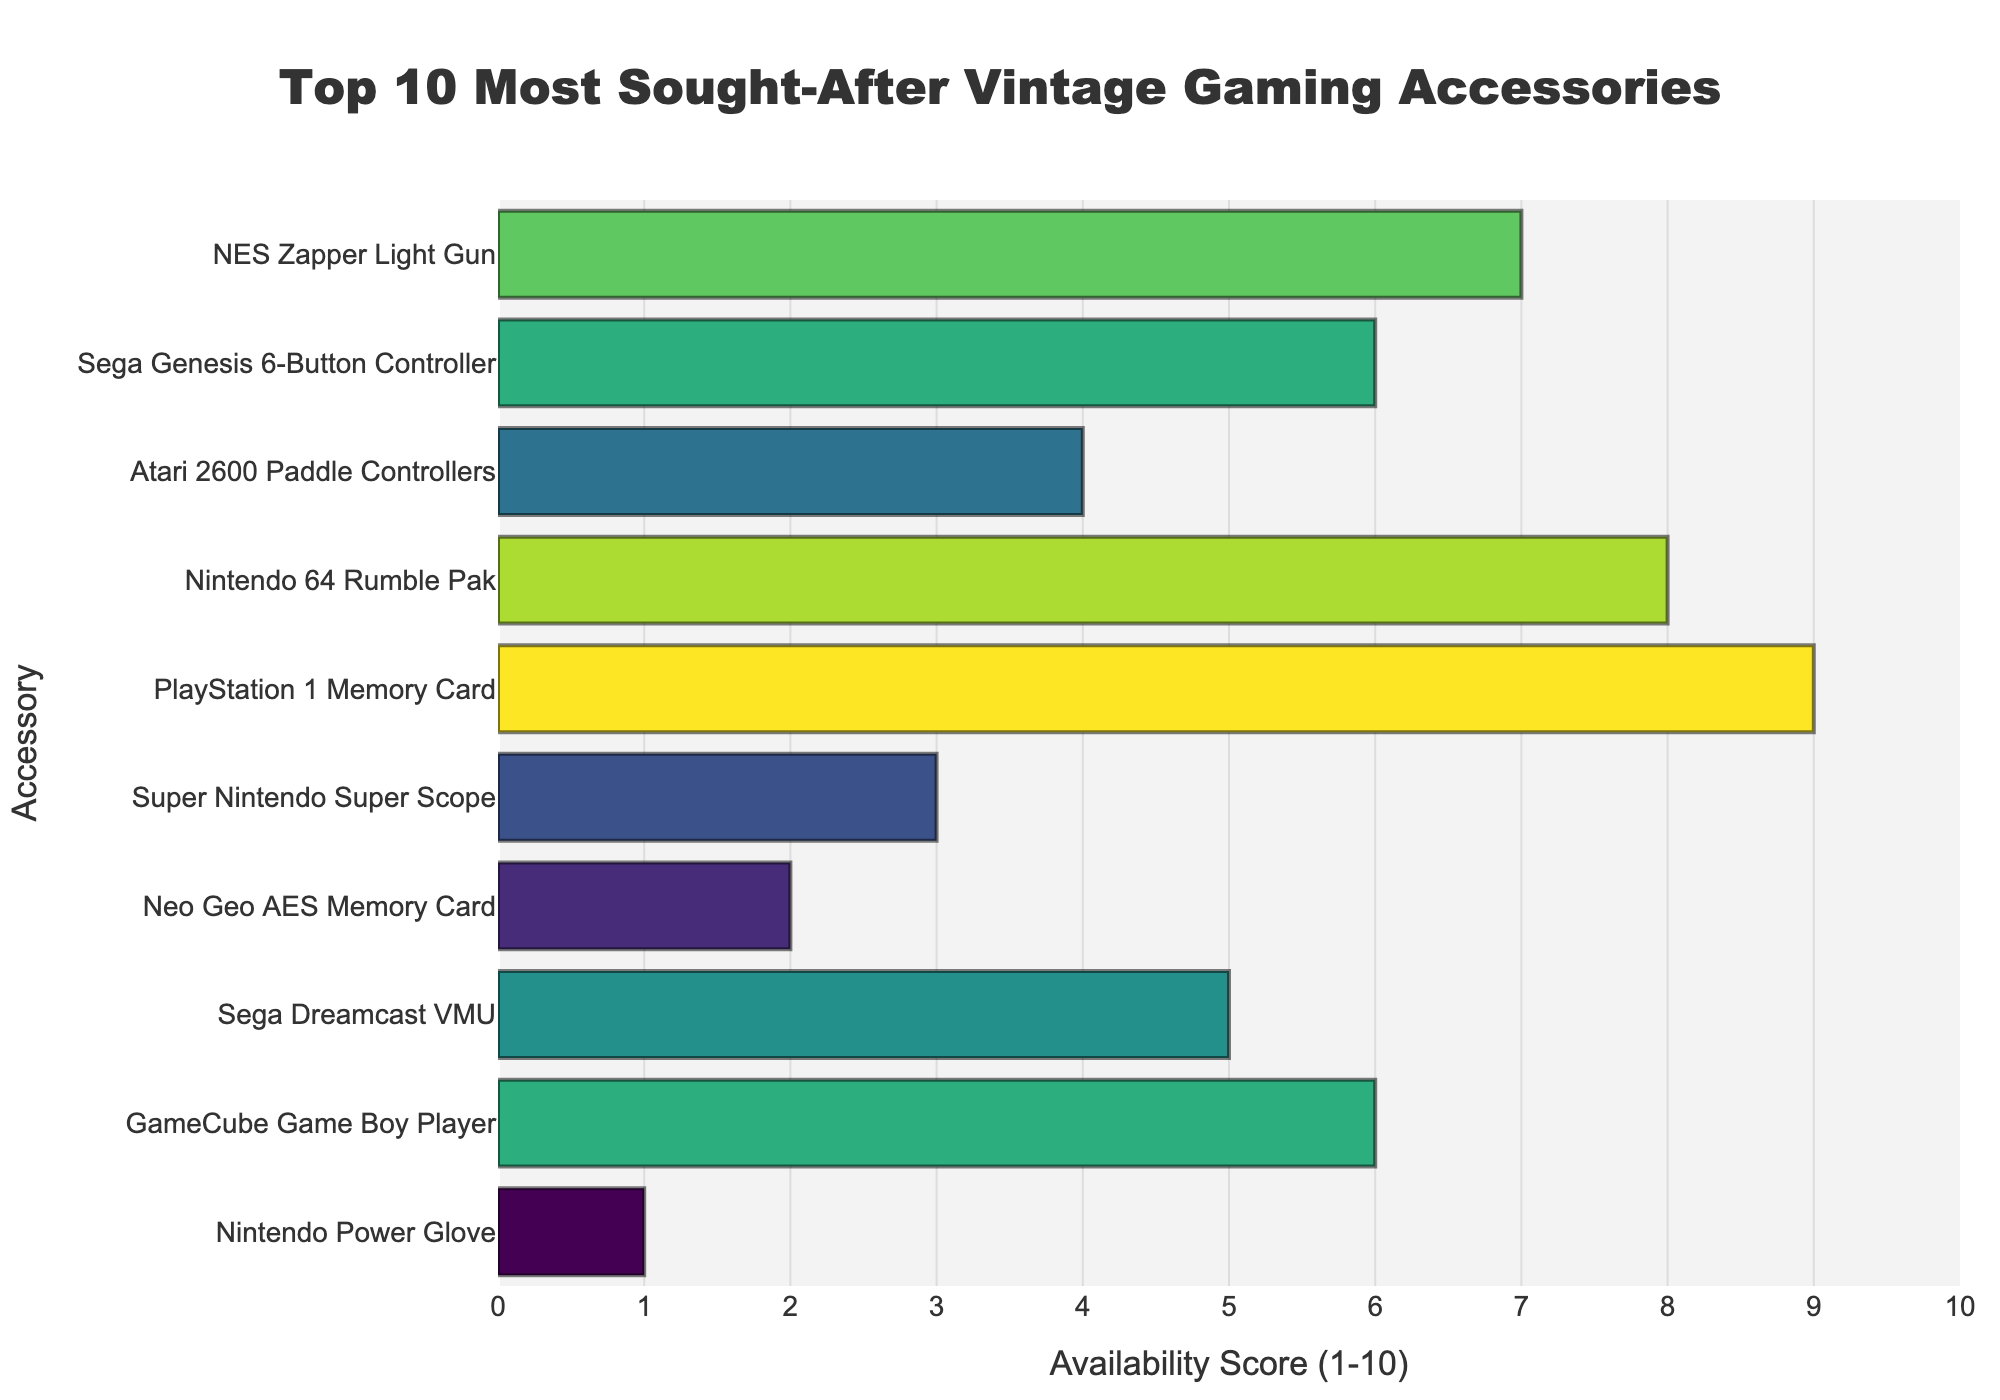Which accessory has the highest availability score? Look at the bar chart and find the accessory with the longest bar, indicating the highest score. The PlayStation 1 Memory Card has the longest bar.
Answer: PlayStation 1 Memory Card Which accessory has the lowest availability score? Identify the accessory with the shortest bar on the bar chart. The Nintendo Power Glove has the shortest bar.
Answer: Nintendo Power Glove What is the difference in availability score between the Nintendo 64 Rumble Pak and the Atari 2600 Paddle Controllers? Find the bars for the Nintendo 64 Rumble Pak and the Atari 2600 Paddle Controllers. The difference in their availability scores is 8 - 4.
Answer: 4 How many accessories have an availability score of 6 or higher? Count the number of bars that are at or above the score of 6 on the x-axis. There are 5 accessories with scores of 6 or higher.
Answer: 5 Which accessories have an availability score of 6? Look for the bars that align with the score of 6 on the x-axis. The Sega Genesis 6-Button Controller and GameCube Game Boy Player align with score 6.
Answer: Sega Genesis 6-Button Controller, GameCube Game Boy Player What is the median availability score of the accessories? List the availability scores in ascending order: 1, 2, 3, 4, 5, 6, 6, 7, 8, 9. The median score is the middle value, which is the average of the 5th and 6th values: (5 + 6) / 2.
Answer: 5.5 How does the visual color of the bars change with the availability score? Observe the color gradient of the bars from left (lower scores) to right (higher scores). The colors transition from darker to lighter shades as the availability score increases.
Answer: From darker to lighter Which accessory has an availability score closest to the average score of all accessories? Calculate the average score: (7 + 6 + 4 + 8 + 9 + 3 + 2 + 5 + 6 + 1) / 10 = 51 / 10 = 5.1. The Sega Dreamcast VMU has a score closest to 5.1.
Answer: Sega Dreamcast VMU How many accessories have a lower availability score than the Sega Genesis 6-Button Controller? Identify the accessories with scores lower than 6: Atari 2600 Paddle Controllers, Super Nintendo Super Scope, Neo Geo AES Memory Card, Sega Dreamcast VMU, Nintendo Power Glove. There are 5 such accessories.
Answer: 5 